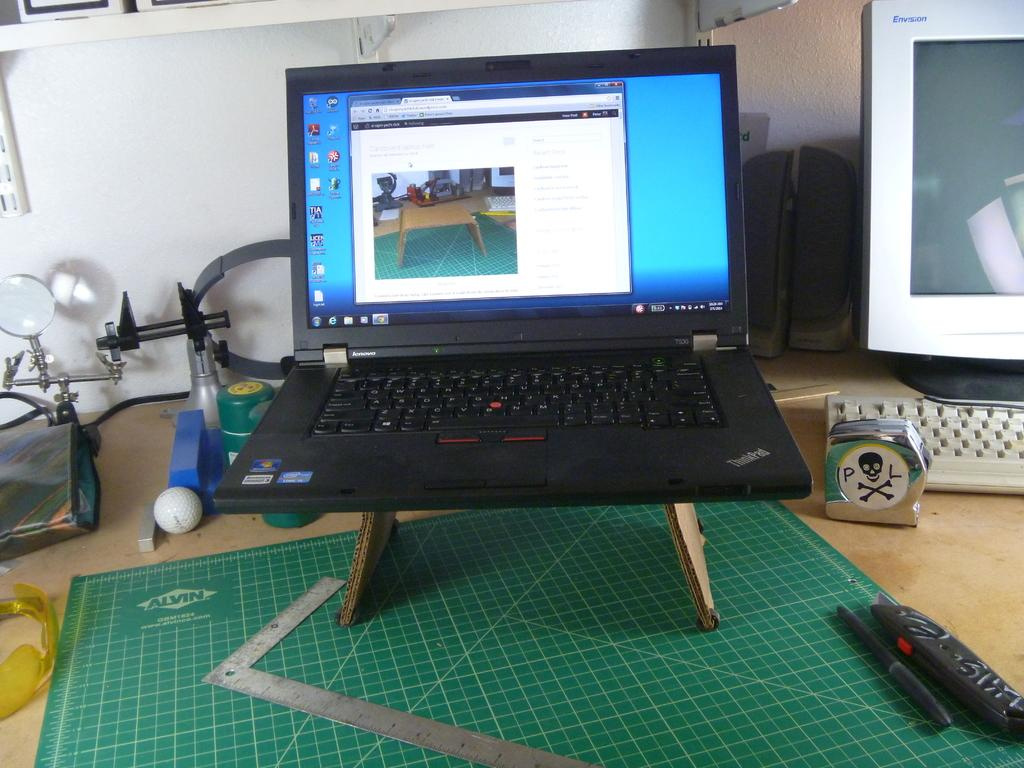<image>
Relay a brief, clear account of the picture shown. A Lenovo laptop sits on top of a green mat on a workspace while an image of that same space is on its screen. 